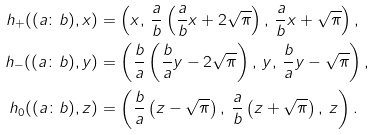Convert formula to latex. <formula><loc_0><loc_0><loc_500><loc_500>h _ { + } ( ( a \colon b ) , x ) & = \left ( x , \, \frac { a } { b } \left ( \frac { a } { b } x + 2 \sqrt { \pi } \right ) , \, \frac { a } { b } x + \sqrt { \pi } \right ) , \\ h _ { - } ( ( a \colon b ) , y ) & = \left ( \frac { b } { a } \left ( \frac { b } { a } y - 2 \sqrt { \pi } \right ) , \, y , \, \frac { b } { a } y - \sqrt { \pi } \right ) , \\ h _ { 0 } ( ( a \colon b ) , z ) & = \left ( \frac { b } { a } \left ( z - \sqrt { \pi } \right ) , \, \frac { a } { b } \left ( z + \sqrt { \pi } \right ) , \, z \right ) .</formula> 